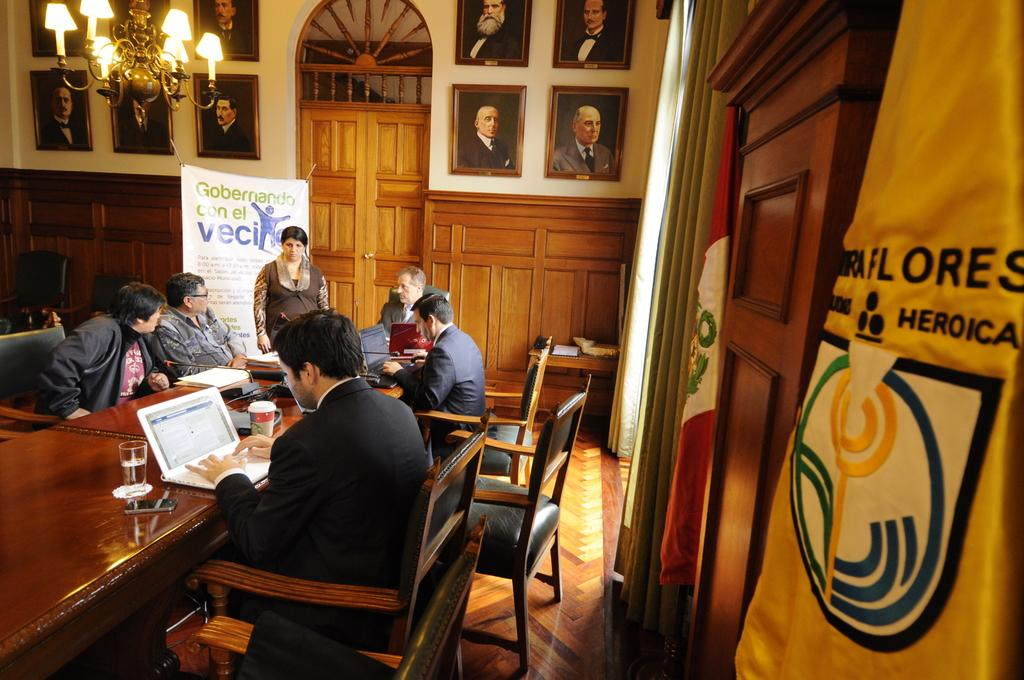What are the people in the image doing? The people in the image are sitting. What can be seen on the wall in the image? There are photo frames on the wall. What electronic device is present on a table in the image? There is a laptop on a table in the image. Can you see a kitten playing chess with a rake in the image? No, there is no kitten, chess, or rake present in the image. 